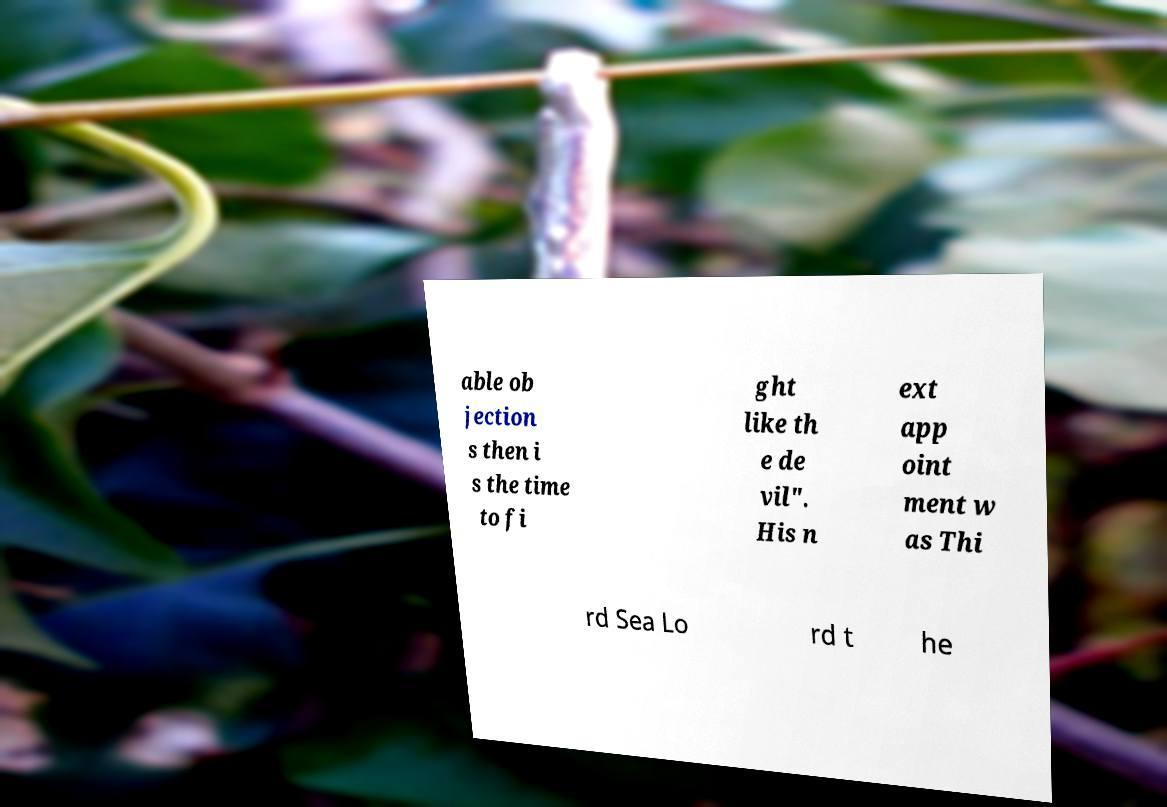Can you accurately transcribe the text from the provided image for me? able ob jection s then i s the time to fi ght like th e de vil". His n ext app oint ment w as Thi rd Sea Lo rd t he 